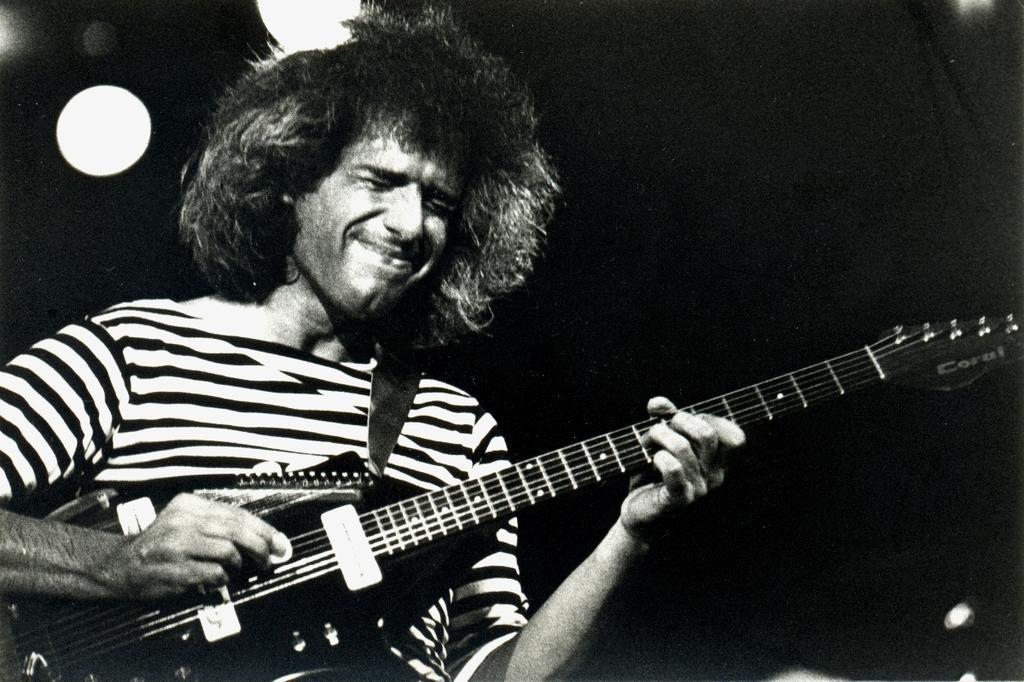Describe this image in one or two sentences. This is a black and white picture. Background portion of the picture is dark. In this picture we can see a man wearing a t-shirt and he is playing a guitar. 